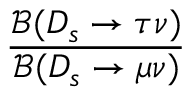<formula> <loc_0><loc_0><loc_500><loc_500>\frac { \mathcal { B } ( D _ { s } \to \tau \nu ) } { \mathcal { B } ( D _ { s } \to \mu \nu ) }</formula> 